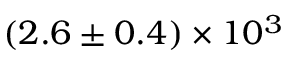<formula> <loc_0><loc_0><loc_500><loc_500>( 2 . 6 \pm 0 . 4 ) \times 1 0 ^ { 3 }</formula> 